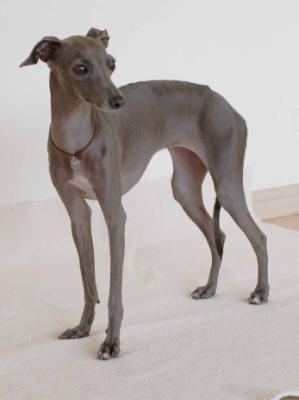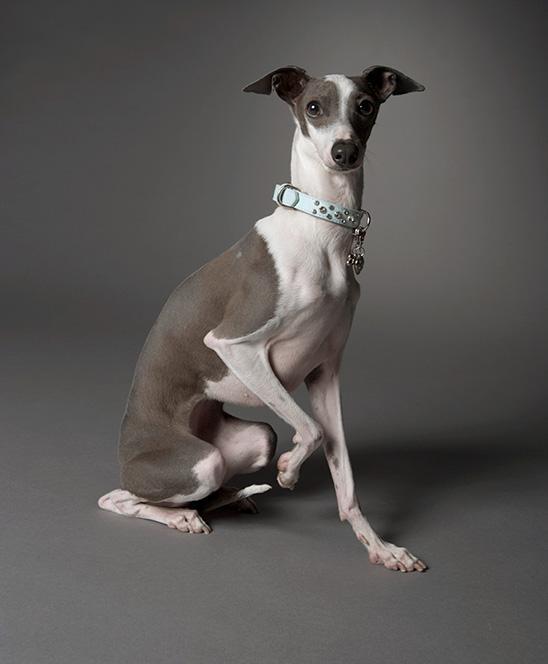The first image is the image on the left, the second image is the image on the right. Considering the images on both sides, is "The right image contains at least one dog wearing a collar." valid? Answer yes or no. Yes. The first image is the image on the left, the second image is the image on the right. Assess this claim about the two images: "At least one dog in the image on the right is wearing a collar.". Correct or not? Answer yes or no. Yes. 